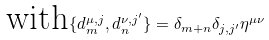Convert formula to latex. <formula><loc_0><loc_0><loc_500><loc_500>\text {with} \{ d _ { m } ^ { \mu , j } , d _ { n } ^ { \nu , j ^ { \prime } } \} = \delta _ { m + n } \delta _ { j , j ^ { \prime } } \eta ^ { \mu \nu }</formula> 